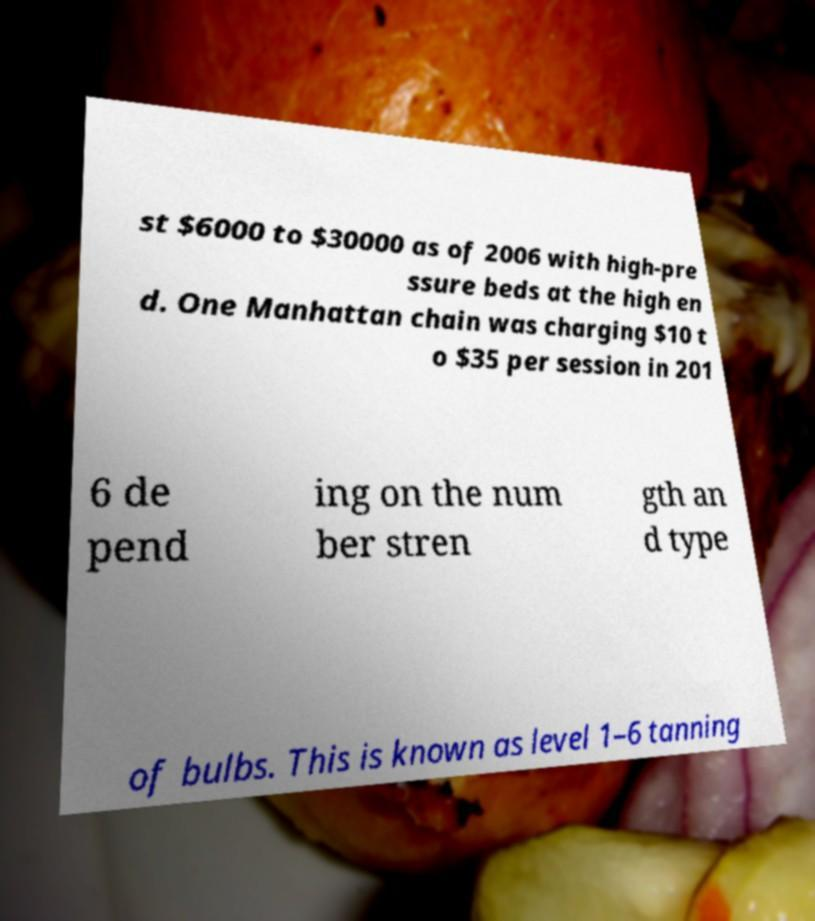Please read and relay the text visible in this image. What does it say? st $6000 to $30000 as of 2006 with high-pre ssure beds at the high en d. One Manhattan chain was charging $10 t o $35 per session in 201 6 de pend ing on the num ber stren gth an d type of bulbs. This is known as level 1–6 tanning 